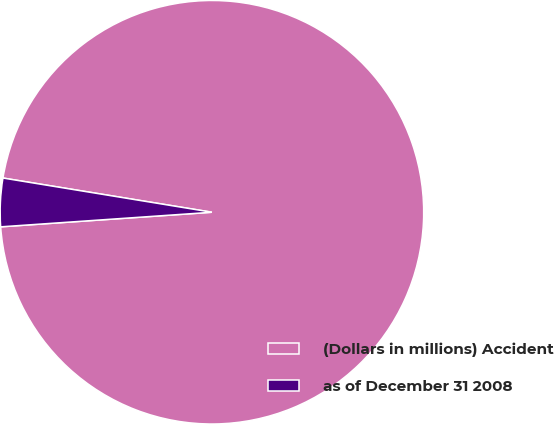Convert chart. <chart><loc_0><loc_0><loc_500><loc_500><pie_chart><fcel>(Dollars in millions) Accident<fcel>as of December 31 2008<nl><fcel>96.32%<fcel>3.68%<nl></chart> 